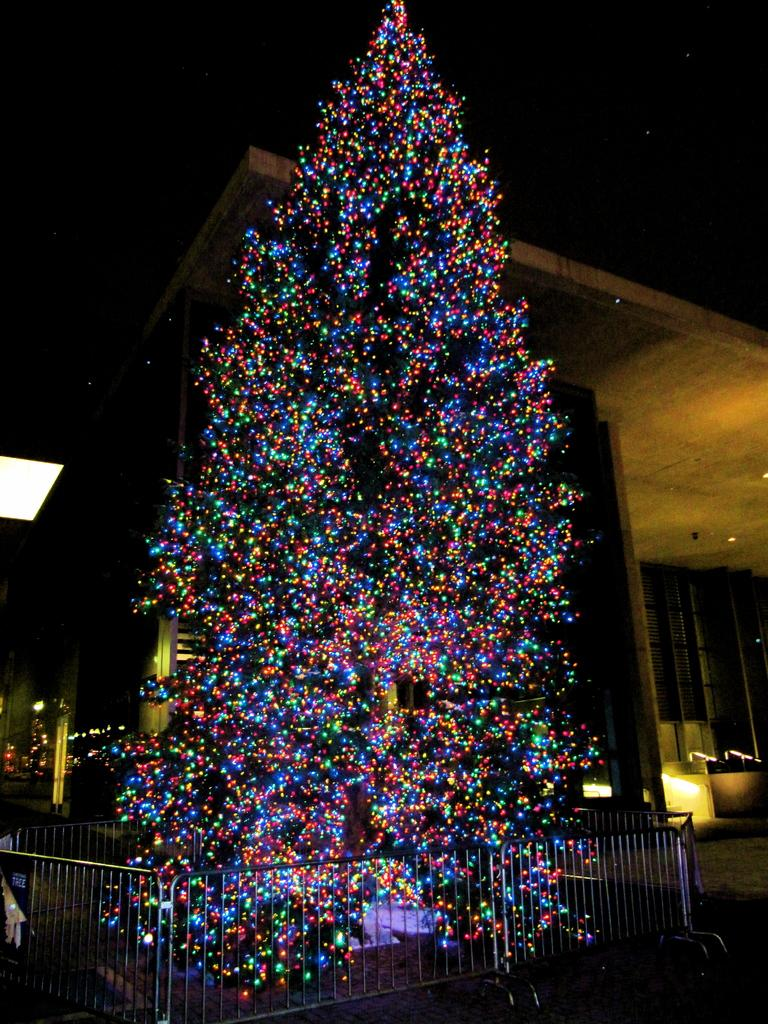What is the main feature of the image? There is a tree with lights in the image. What is located in front of the tree? There is a fence in front of the tree. What can be seen in the background of the image? There is a building and lights visible in the background. What type of library can be seen in the image? There is no library present in the image; it features a tree with lights, a fence, and a building in the background. How low are the lights in the image? The question about the height of the lights is not relevant, as the facts provided do not mention the height of the lights. 